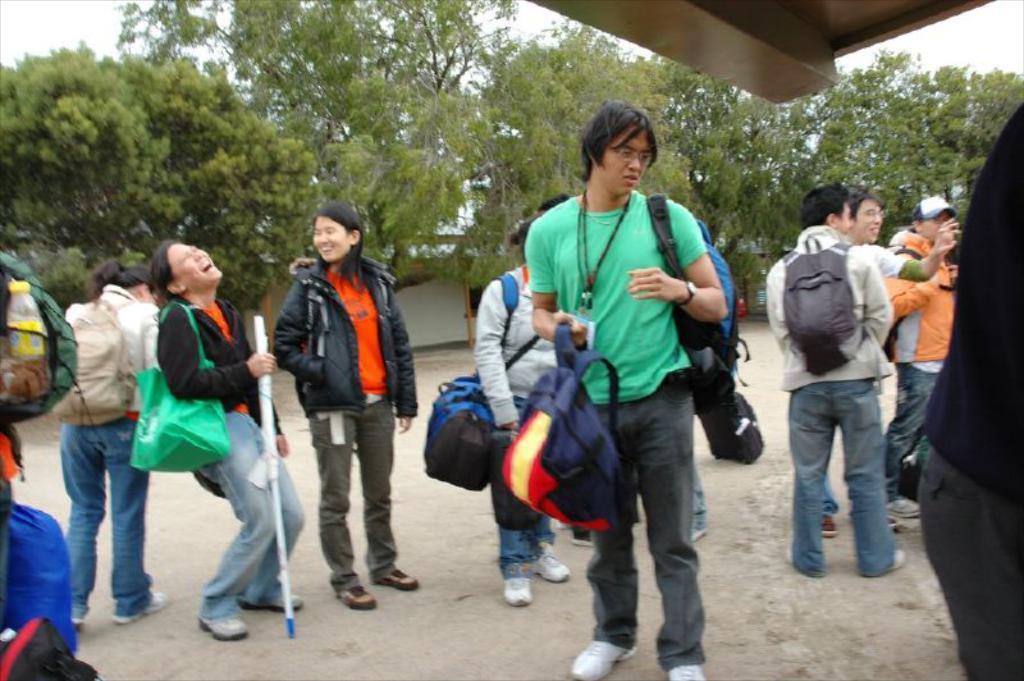In one or two sentences, can you explain what this image depicts? In this image we can see some persons, bags, pole and other objects. In the background of the image there are some trees and other objects. At the top of the image there is an object and the sky. At the bottom of the object there is the floor. 